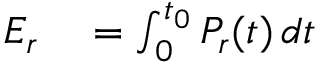Convert formula to latex. <formula><loc_0><loc_0><loc_500><loc_500>\begin{array} { r l } { E _ { r } } & = \int _ { 0 } ^ { t _ { 0 } } P _ { r } ( t ) \, d t } \end{array}</formula> 